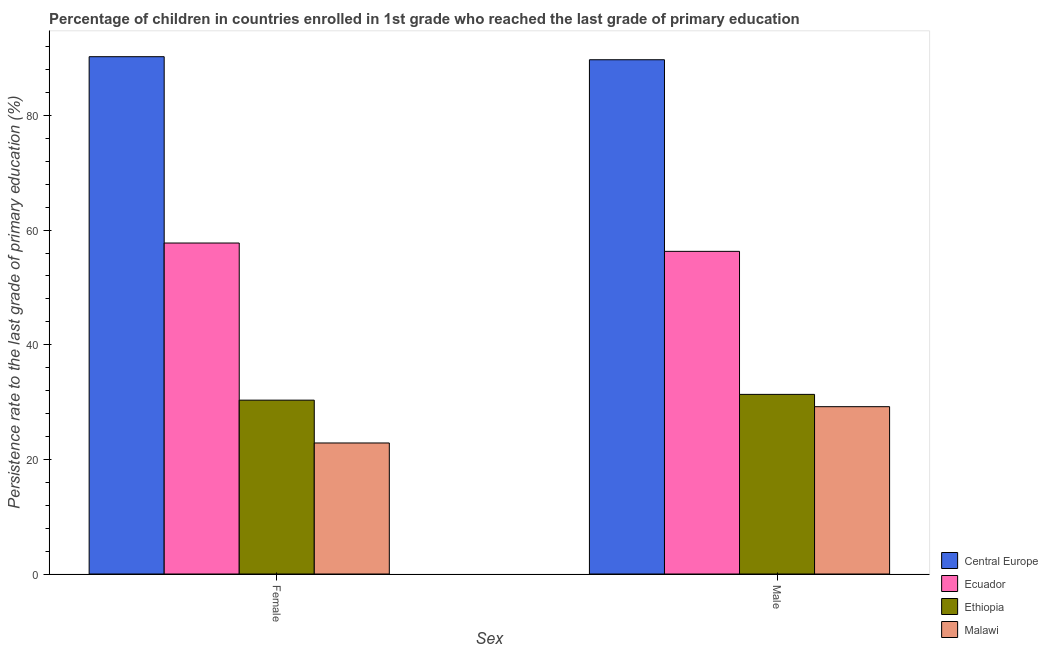How many bars are there on the 1st tick from the right?
Provide a short and direct response. 4. What is the persistence rate of female students in Central Europe?
Your answer should be very brief. 90.25. Across all countries, what is the maximum persistence rate of male students?
Your response must be concise. 89.72. Across all countries, what is the minimum persistence rate of male students?
Give a very brief answer. 29.19. In which country was the persistence rate of female students maximum?
Make the answer very short. Central Europe. In which country was the persistence rate of male students minimum?
Your answer should be very brief. Malawi. What is the total persistence rate of female students in the graph?
Your response must be concise. 201.19. What is the difference between the persistence rate of male students in Malawi and that in Central Europe?
Ensure brevity in your answer.  -60.53. What is the difference between the persistence rate of female students in Ecuador and the persistence rate of male students in Ethiopia?
Ensure brevity in your answer.  26.41. What is the average persistence rate of male students per country?
Offer a very short reply. 51.64. What is the difference between the persistence rate of female students and persistence rate of male students in Central Europe?
Your response must be concise. 0.53. In how many countries, is the persistence rate of male students greater than 88 %?
Provide a succinct answer. 1. What is the ratio of the persistence rate of male students in Ethiopia to that in Ecuador?
Your answer should be very brief. 0.56. What does the 3rd bar from the left in Female represents?
Your response must be concise. Ethiopia. What does the 2nd bar from the right in Female represents?
Give a very brief answer. Ethiopia. How many bars are there?
Offer a terse response. 8. Are all the bars in the graph horizontal?
Your response must be concise. No. Are the values on the major ticks of Y-axis written in scientific E-notation?
Make the answer very short. No. How are the legend labels stacked?
Your response must be concise. Vertical. What is the title of the graph?
Make the answer very short. Percentage of children in countries enrolled in 1st grade who reached the last grade of primary education. Does "Brazil" appear as one of the legend labels in the graph?
Provide a short and direct response. No. What is the label or title of the X-axis?
Give a very brief answer. Sex. What is the label or title of the Y-axis?
Your answer should be compact. Persistence rate to the last grade of primary education (%). What is the Persistence rate to the last grade of primary education (%) in Central Europe in Female?
Offer a very short reply. 90.25. What is the Persistence rate to the last grade of primary education (%) of Ecuador in Female?
Offer a very short reply. 57.74. What is the Persistence rate to the last grade of primary education (%) in Ethiopia in Female?
Your response must be concise. 30.33. What is the Persistence rate to the last grade of primary education (%) in Malawi in Female?
Give a very brief answer. 22.86. What is the Persistence rate to the last grade of primary education (%) of Central Europe in Male?
Offer a terse response. 89.72. What is the Persistence rate to the last grade of primary education (%) of Ecuador in Male?
Ensure brevity in your answer.  56.29. What is the Persistence rate to the last grade of primary education (%) in Ethiopia in Male?
Your answer should be very brief. 31.34. What is the Persistence rate to the last grade of primary education (%) of Malawi in Male?
Offer a very short reply. 29.19. Across all Sex, what is the maximum Persistence rate to the last grade of primary education (%) in Central Europe?
Your answer should be very brief. 90.25. Across all Sex, what is the maximum Persistence rate to the last grade of primary education (%) of Ecuador?
Provide a short and direct response. 57.74. Across all Sex, what is the maximum Persistence rate to the last grade of primary education (%) of Ethiopia?
Your answer should be compact. 31.34. Across all Sex, what is the maximum Persistence rate to the last grade of primary education (%) in Malawi?
Ensure brevity in your answer.  29.19. Across all Sex, what is the minimum Persistence rate to the last grade of primary education (%) in Central Europe?
Offer a very short reply. 89.72. Across all Sex, what is the minimum Persistence rate to the last grade of primary education (%) of Ecuador?
Give a very brief answer. 56.29. Across all Sex, what is the minimum Persistence rate to the last grade of primary education (%) of Ethiopia?
Give a very brief answer. 30.33. Across all Sex, what is the minimum Persistence rate to the last grade of primary education (%) in Malawi?
Your answer should be compact. 22.86. What is the total Persistence rate to the last grade of primary education (%) in Central Europe in the graph?
Keep it short and to the point. 179.98. What is the total Persistence rate to the last grade of primary education (%) in Ecuador in the graph?
Ensure brevity in your answer.  114.04. What is the total Persistence rate to the last grade of primary education (%) of Ethiopia in the graph?
Your response must be concise. 61.67. What is the total Persistence rate to the last grade of primary education (%) in Malawi in the graph?
Provide a short and direct response. 52.05. What is the difference between the Persistence rate to the last grade of primary education (%) in Central Europe in Female and that in Male?
Your response must be concise. 0.53. What is the difference between the Persistence rate to the last grade of primary education (%) in Ecuador in Female and that in Male?
Keep it short and to the point. 1.45. What is the difference between the Persistence rate to the last grade of primary education (%) in Ethiopia in Female and that in Male?
Provide a succinct answer. -1.01. What is the difference between the Persistence rate to the last grade of primary education (%) of Malawi in Female and that in Male?
Make the answer very short. -6.33. What is the difference between the Persistence rate to the last grade of primary education (%) of Central Europe in Female and the Persistence rate to the last grade of primary education (%) of Ecuador in Male?
Give a very brief answer. 33.96. What is the difference between the Persistence rate to the last grade of primary education (%) of Central Europe in Female and the Persistence rate to the last grade of primary education (%) of Ethiopia in Male?
Give a very brief answer. 58.92. What is the difference between the Persistence rate to the last grade of primary education (%) in Central Europe in Female and the Persistence rate to the last grade of primary education (%) in Malawi in Male?
Provide a short and direct response. 61.06. What is the difference between the Persistence rate to the last grade of primary education (%) of Ecuador in Female and the Persistence rate to the last grade of primary education (%) of Ethiopia in Male?
Give a very brief answer. 26.41. What is the difference between the Persistence rate to the last grade of primary education (%) of Ecuador in Female and the Persistence rate to the last grade of primary education (%) of Malawi in Male?
Your answer should be very brief. 28.55. What is the difference between the Persistence rate to the last grade of primary education (%) in Ethiopia in Female and the Persistence rate to the last grade of primary education (%) in Malawi in Male?
Your answer should be very brief. 1.14. What is the average Persistence rate to the last grade of primary education (%) in Central Europe per Sex?
Your response must be concise. 89.99. What is the average Persistence rate to the last grade of primary education (%) of Ecuador per Sex?
Your answer should be compact. 57.02. What is the average Persistence rate to the last grade of primary education (%) of Ethiopia per Sex?
Provide a short and direct response. 30.83. What is the average Persistence rate to the last grade of primary education (%) of Malawi per Sex?
Provide a short and direct response. 26.03. What is the difference between the Persistence rate to the last grade of primary education (%) of Central Europe and Persistence rate to the last grade of primary education (%) of Ecuador in Female?
Offer a terse response. 32.51. What is the difference between the Persistence rate to the last grade of primary education (%) of Central Europe and Persistence rate to the last grade of primary education (%) of Ethiopia in Female?
Offer a very short reply. 59.92. What is the difference between the Persistence rate to the last grade of primary education (%) of Central Europe and Persistence rate to the last grade of primary education (%) of Malawi in Female?
Keep it short and to the point. 67.39. What is the difference between the Persistence rate to the last grade of primary education (%) of Ecuador and Persistence rate to the last grade of primary education (%) of Ethiopia in Female?
Your answer should be very brief. 27.41. What is the difference between the Persistence rate to the last grade of primary education (%) in Ecuador and Persistence rate to the last grade of primary education (%) in Malawi in Female?
Make the answer very short. 34.88. What is the difference between the Persistence rate to the last grade of primary education (%) of Ethiopia and Persistence rate to the last grade of primary education (%) of Malawi in Female?
Ensure brevity in your answer.  7.47. What is the difference between the Persistence rate to the last grade of primary education (%) in Central Europe and Persistence rate to the last grade of primary education (%) in Ecuador in Male?
Offer a very short reply. 33.43. What is the difference between the Persistence rate to the last grade of primary education (%) in Central Europe and Persistence rate to the last grade of primary education (%) in Ethiopia in Male?
Provide a succinct answer. 58.38. What is the difference between the Persistence rate to the last grade of primary education (%) of Central Europe and Persistence rate to the last grade of primary education (%) of Malawi in Male?
Give a very brief answer. 60.53. What is the difference between the Persistence rate to the last grade of primary education (%) in Ecuador and Persistence rate to the last grade of primary education (%) in Ethiopia in Male?
Your answer should be very brief. 24.95. What is the difference between the Persistence rate to the last grade of primary education (%) of Ecuador and Persistence rate to the last grade of primary education (%) of Malawi in Male?
Your answer should be compact. 27.1. What is the difference between the Persistence rate to the last grade of primary education (%) of Ethiopia and Persistence rate to the last grade of primary education (%) of Malawi in Male?
Offer a terse response. 2.15. What is the ratio of the Persistence rate to the last grade of primary education (%) in Central Europe in Female to that in Male?
Give a very brief answer. 1.01. What is the ratio of the Persistence rate to the last grade of primary education (%) of Ecuador in Female to that in Male?
Provide a short and direct response. 1.03. What is the ratio of the Persistence rate to the last grade of primary education (%) in Ethiopia in Female to that in Male?
Provide a short and direct response. 0.97. What is the ratio of the Persistence rate to the last grade of primary education (%) of Malawi in Female to that in Male?
Keep it short and to the point. 0.78. What is the difference between the highest and the second highest Persistence rate to the last grade of primary education (%) of Central Europe?
Give a very brief answer. 0.53. What is the difference between the highest and the second highest Persistence rate to the last grade of primary education (%) of Ecuador?
Your response must be concise. 1.45. What is the difference between the highest and the second highest Persistence rate to the last grade of primary education (%) of Ethiopia?
Your response must be concise. 1.01. What is the difference between the highest and the second highest Persistence rate to the last grade of primary education (%) in Malawi?
Your answer should be compact. 6.33. What is the difference between the highest and the lowest Persistence rate to the last grade of primary education (%) of Central Europe?
Offer a terse response. 0.53. What is the difference between the highest and the lowest Persistence rate to the last grade of primary education (%) in Ecuador?
Provide a succinct answer. 1.45. What is the difference between the highest and the lowest Persistence rate to the last grade of primary education (%) in Ethiopia?
Provide a succinct answer. 1.01. What is the difference between the highest and the lowest Persistence rate to the last grade of primary education (%) of Malawi?
Make the answer very short. 6.33. 